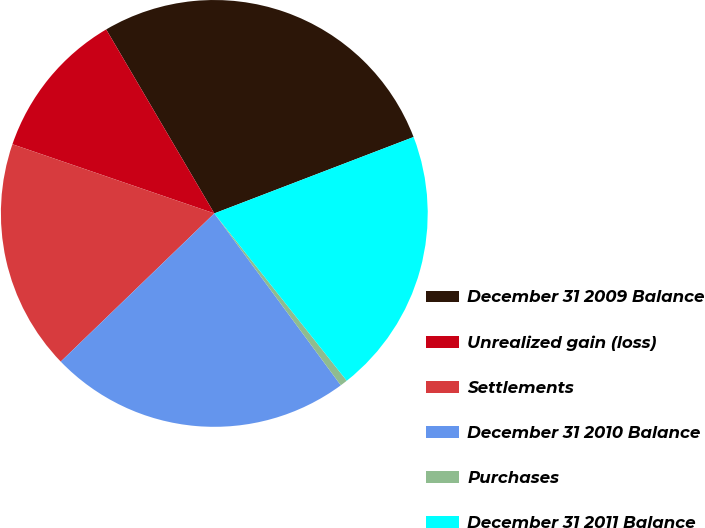Convert chart to OTSL. <chart><loc_0><loc_0><loc_500><loc_500><pie_chart><fcel>December 31 2009 Balance<fcel>Unrealized gain (loss)<fcel>Settlements<fcel>December 31 2010 Balance<fcel>Purchases<fcel>December 31 2011 Balance<nl><fcel>27.63%<fcel>11.29%<fcel>17.47%<fcel>22.88%<fcel>0.56%<fcel>20.17%<nl></chart> 